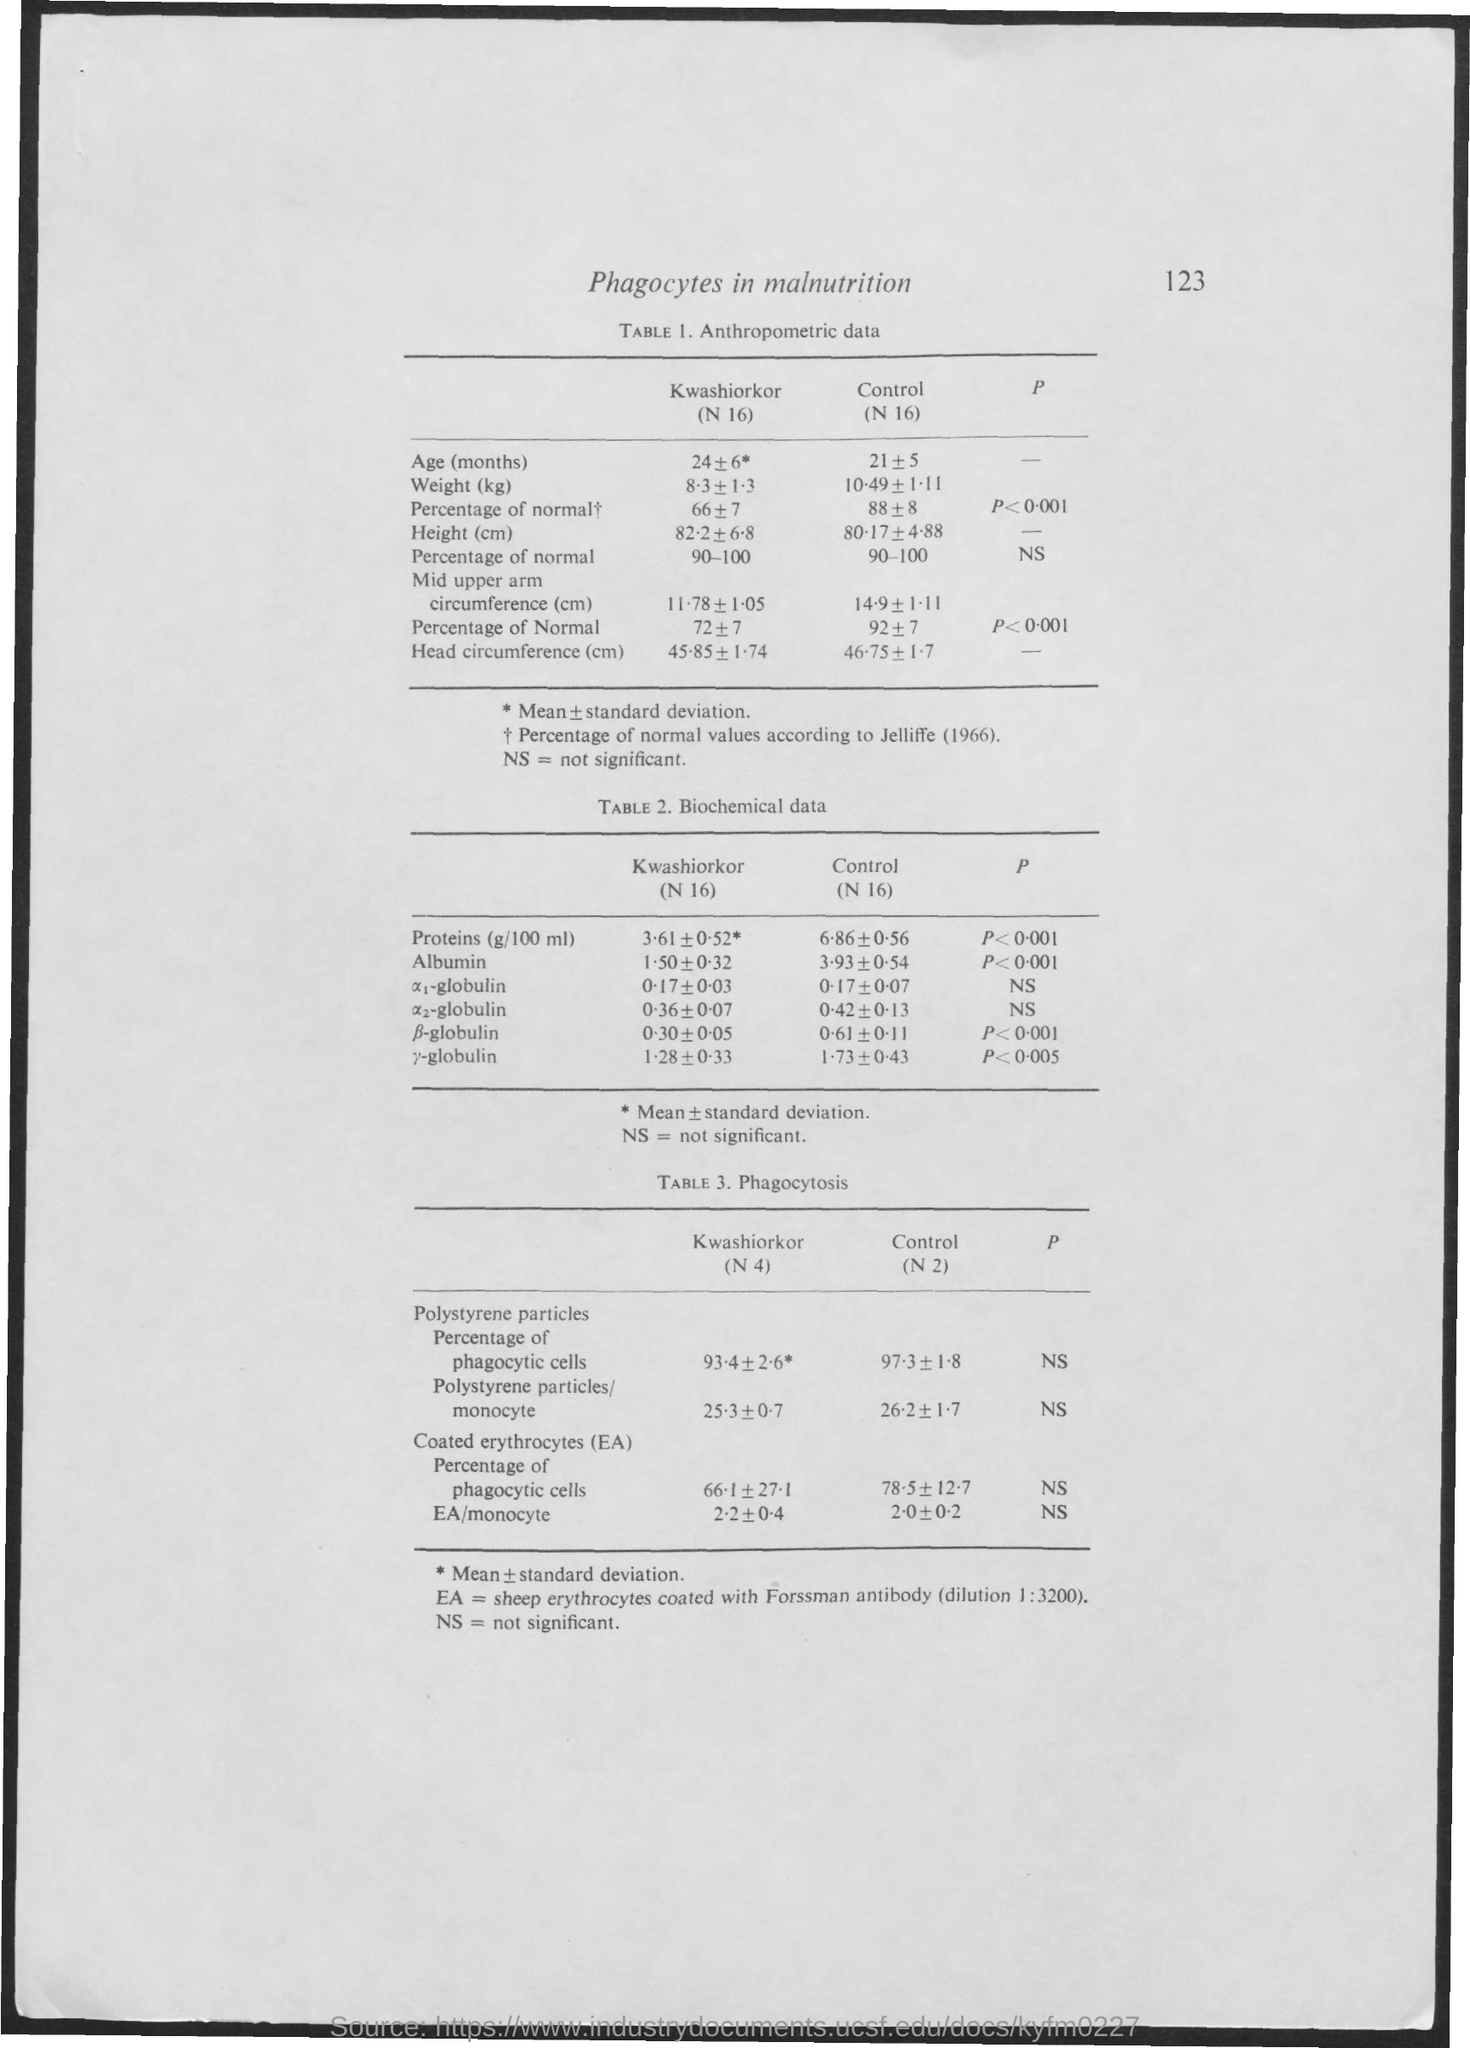Identify some key points in this picture. According to Jelliffe, the percentage of normal values is... The title of table 1 is 'Anthropometric data,' which provides information on various measurements of the human body. The table indicates that the experiment is focused on investigating the effects of EA (not specified what it stands for) on sheep erythrocytes that have been coated with Forssman antibody (dilution 1:3200). Phagocytes in malnutrition have been given the title of [insert title here]. The title of Table 3 is "Phagocytosis". 